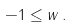<formula> <loc_0><loc_0><loc_500><loc_500>- 1 \leq w \, .</formula> 